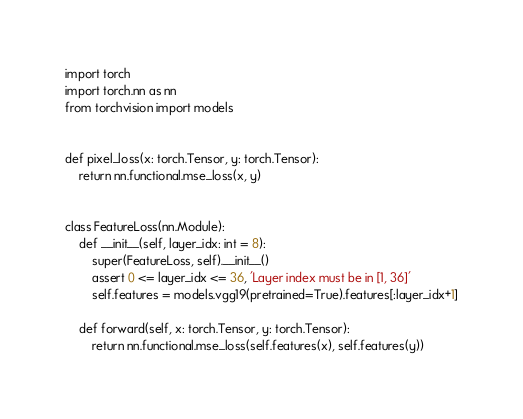Convert code to text. <code><loc_0><loc_0><loc_500><loc_500><_Python_>import torch
import torch.nn as nn
from torchvision import models


def pixel_loss(x: torch.Tensor, y: torch.Tensor):
    return nn.functional.mse_loss(x, y)


class FeatureLoss(nn.Module):
    def __init__(self, layer_idx: int = 8):
        super(FeatureLoss, self).__init__()
        assert 0 <= layer_idx <= 36, 'Layer index must be in [1, 36]'
        self.features = models.vgg19(pretrained=True).features[:layer_idx+1]

    def forward(self, x: torch.Tensor, y: torch.Tensor):
        return nn.functional.mse_loss(self.features(x), self.features(y))
</code> 